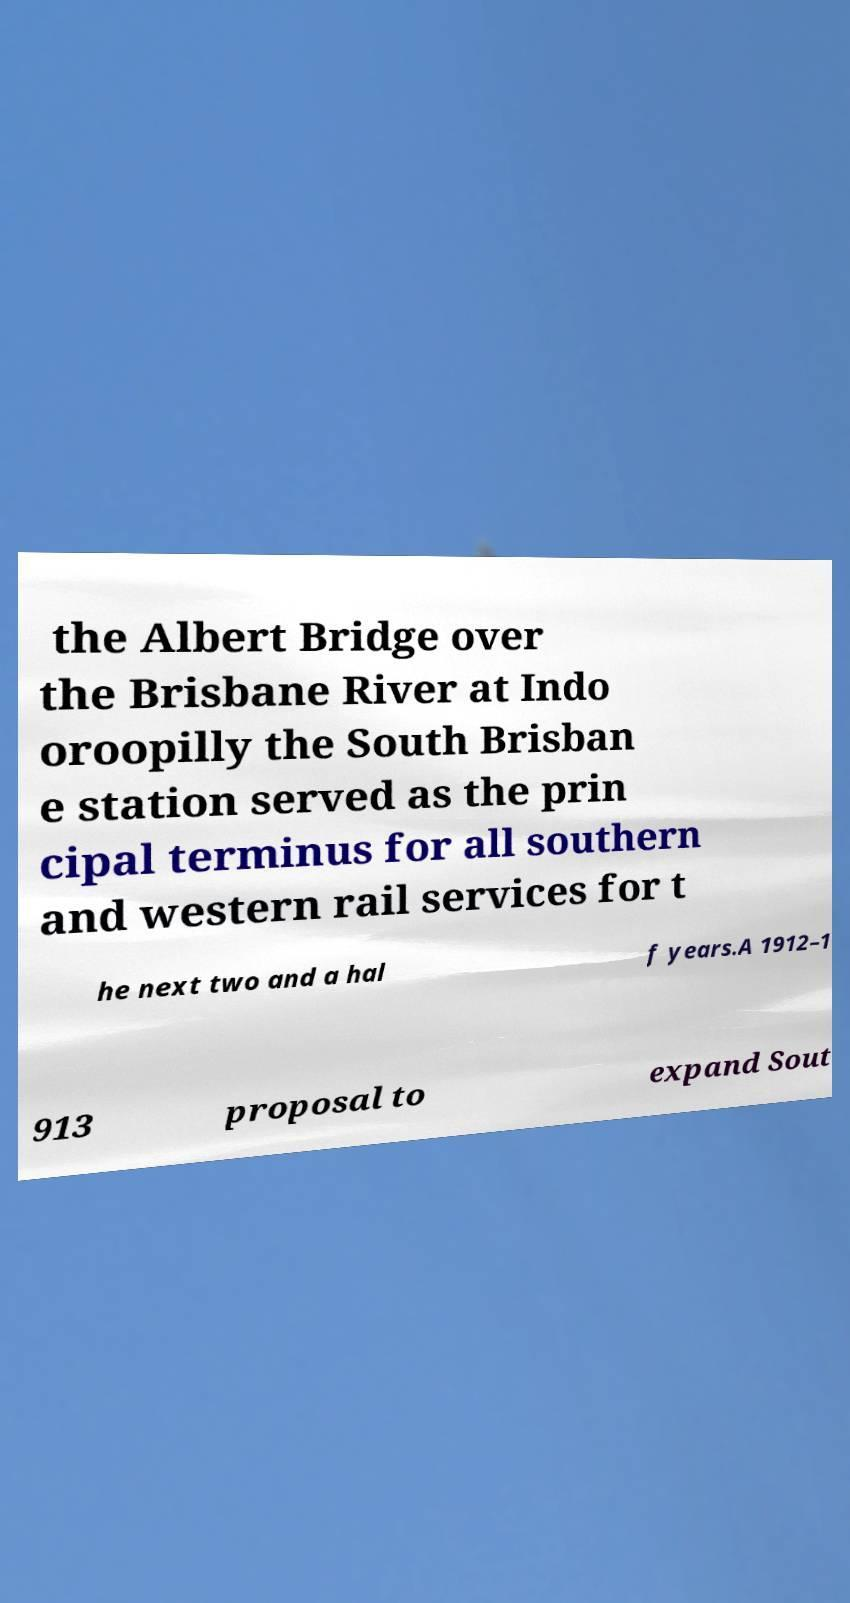There's text embedded in this image that I need extracted. Can you transcribe it verbatim? the Albert Bridge over the Brisbane River at Indo oroopilly the South Brisban e station served as the prin cipal terminus for all southern and western rail services for t he next two and a hal f years.A 1912–1 913 proposal to expand Sout 